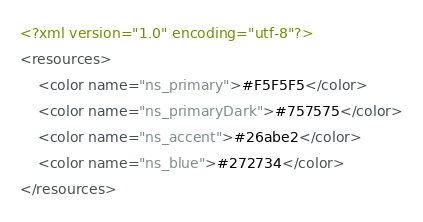<code> <loc_0><loc_0><loc_500><loc_500><_XML_><?xml version="1.0" encoding="utf-8"?>
<resources>
    <color name="ns_primary">#F5F5F5</color>
	<color name="ns_primaryDark">#757575</color>
	<color name="ns_accent">#26abe2</color>
    <color name="ns_blue">#272734</color>
</resources></code> 